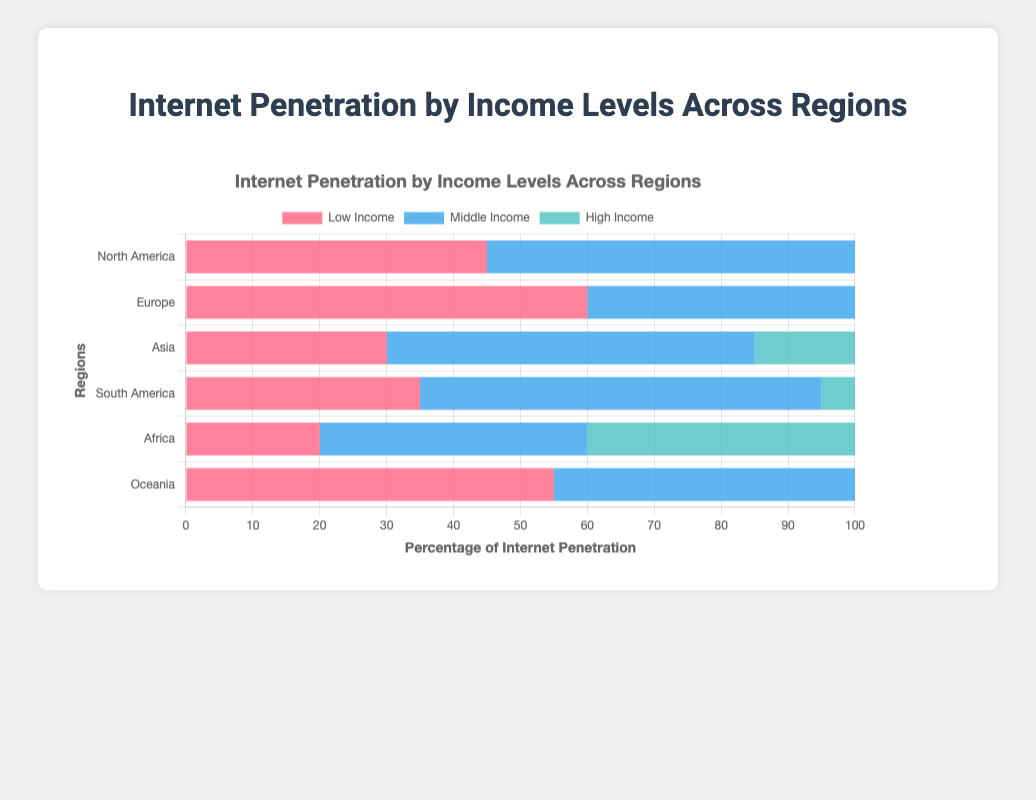Which region has the highest internet penetration in low-income households? To find the answer, look at the "Low Income" section for each region. The values are: North America (45), Europe (60), Asia (30), South America (35), Africa (20), Oceania (55). Europe has the highest value at 60.
Answer: Europe What is the difference in internet penetration between high-income households in North America and Asia? Identify the internet penetration values for high-income households in North America (90) and Asia (80). Subtract the value for Asia from that for North America: 90 - 80 = 10.
Answer: 10 Which region shows the largest gap between low-income and high-income internet penetration? Calculate the gap between low-income and high-income penetration for each region: North America (90 - 45 = 45), Europe (95 - 60 = 35), Asia (80 - 30 = 50), South America (85 - 35 = 50), Africa (65 - 20 = 45), Oceania (90 - 55 = 35). Both Asia and South America show the largest gap of 50.
Answer: Asia/South America Is internet penetration for middle-income households in Oceania higher than in South America? Compare the values for middle-income households for both regions: Oceania (75) and South America (60). Since 75 is greater than 60, internet penetration in Oceania is higher.
Answer: Yes Which region has the lowest internet penetration in high-income households? Look at the "High Income" section for each region. The values are: North America (90), Europe (95), Asia (80), South America (85), Africa (65), Oceania (90). Africa has the lowest value at 65.
Answer: Africa What is the average internet penetration for middle-income households across all regions? Sum the values for middle-income internet penetration: (70 + 80 + 55 + 60 + 40 + 75) = 380. Divide by the number of regions (6): 380 / 6 ≈ 63.33.
Answer: 63.33 Which region has the smallest variation in internet penetration between income levels? Calculate the range (high - low) for each region: North America (90 - 45 = 45), Europe (95 - 60 = 35), Asia (80 - 30 = 50), South America (85 - 35 = 50), Africa (65 - 20 = 45), Oceania (90 - 55 = 35). Europe and Oceania both have the smallest variation of 35.
Answer: Europe/Oceania Are there any regions where high-income internet penetration is below 85%? Look at the "High Income" section for each region: North America (90), Europe (95), Asia (80), South America (85), Africa (65), Oceania (90). Both Asia and Africa have less than 85%.
Answer: Asia/Africa 